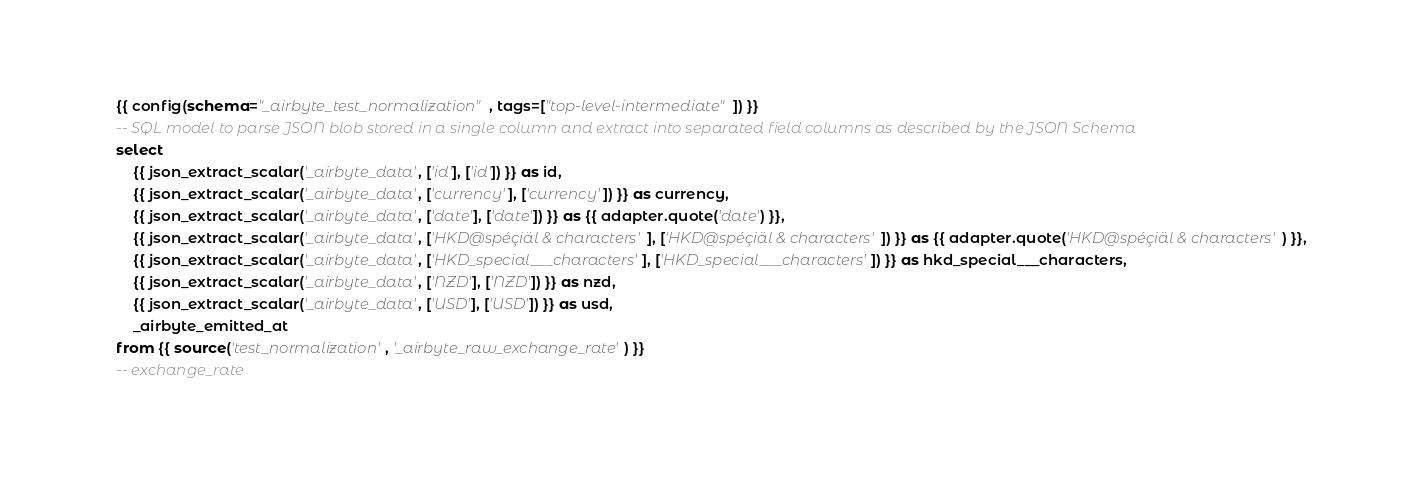<code> <loc_0><loc_0><loc_500><loc_500><_SQL_>{{ config(schema="_airbyte_test_normalization", tags=["top-level-intermediate"]) }}
-- SQL model to parse JSON blob stored in a single column and extract into separated field columns as described by the JSON Schema
select
    {{ json_extract_scalar('_airbyte_data', ['id'], ['id']) }} as id,
    {{ json_extract_scalar('_airbyte_data', ['currency'], ['currency']) }} as currency,
    {{ json_extract_scalar('_airbyte_data', ['date'], ['date']) }} as {{ adapter.quote('date') }},
    {{ json_extract_scalar('_airbyte_data', ['HKD@spéçiäl & characters'], ['HKD@spéçiäl & characters']) }} as {{ adapter.quote('HKD@spéçiäl & characters') }},
    {{ json_extract_scalar('_airbyte_data', ['HKD_special___characters'], ['HKD_special___characters']) }} as hkd_special___characters,
    {{ json_extract_scalar('_airbyte_data', ['NZD'], ['NZD']) }} as nzd,
    {{ json_extract_scalar('_airbyte_data', ['USD'], ['USD']) }} as usd,
    _airbyte_emitted_at
from {{ source('test_normalization', '_airbyte_raw_exchange_rate') }}
-- exchange_rate

</code> 